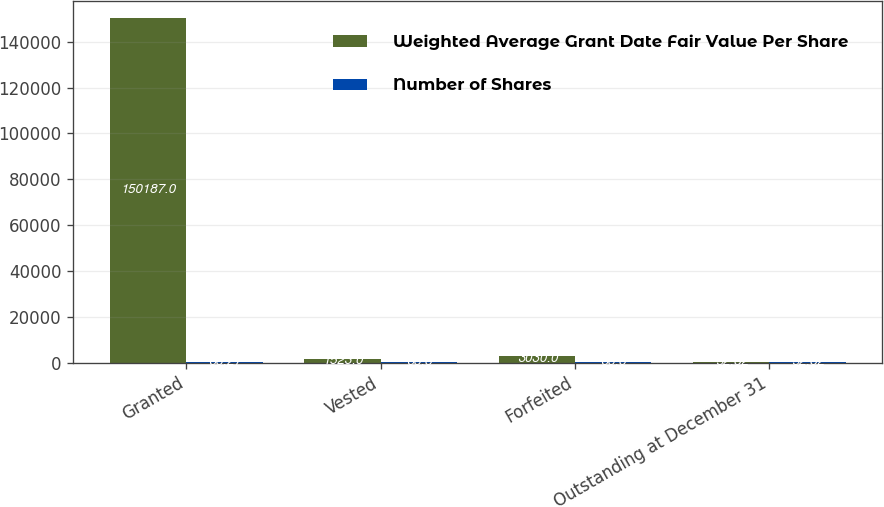Convert chart. <chart><loc_0><loc_0><loc_500><loc_500><stacked_bar_chart><ecel><fcel>Granted<fcel>Vested<fcel>Forfeited<fcel>Outstanding at December 31<nl><fcel>Weighted Average Grant Date Fair Value Per Share<fcel>150187<fcel>1523<fcel>3030<fcel>52.82<nl><fcel>Number of Shares<fcel>33.27<fcel>33.3<fcel>33.3<fcel>52.82<nl></chart> 